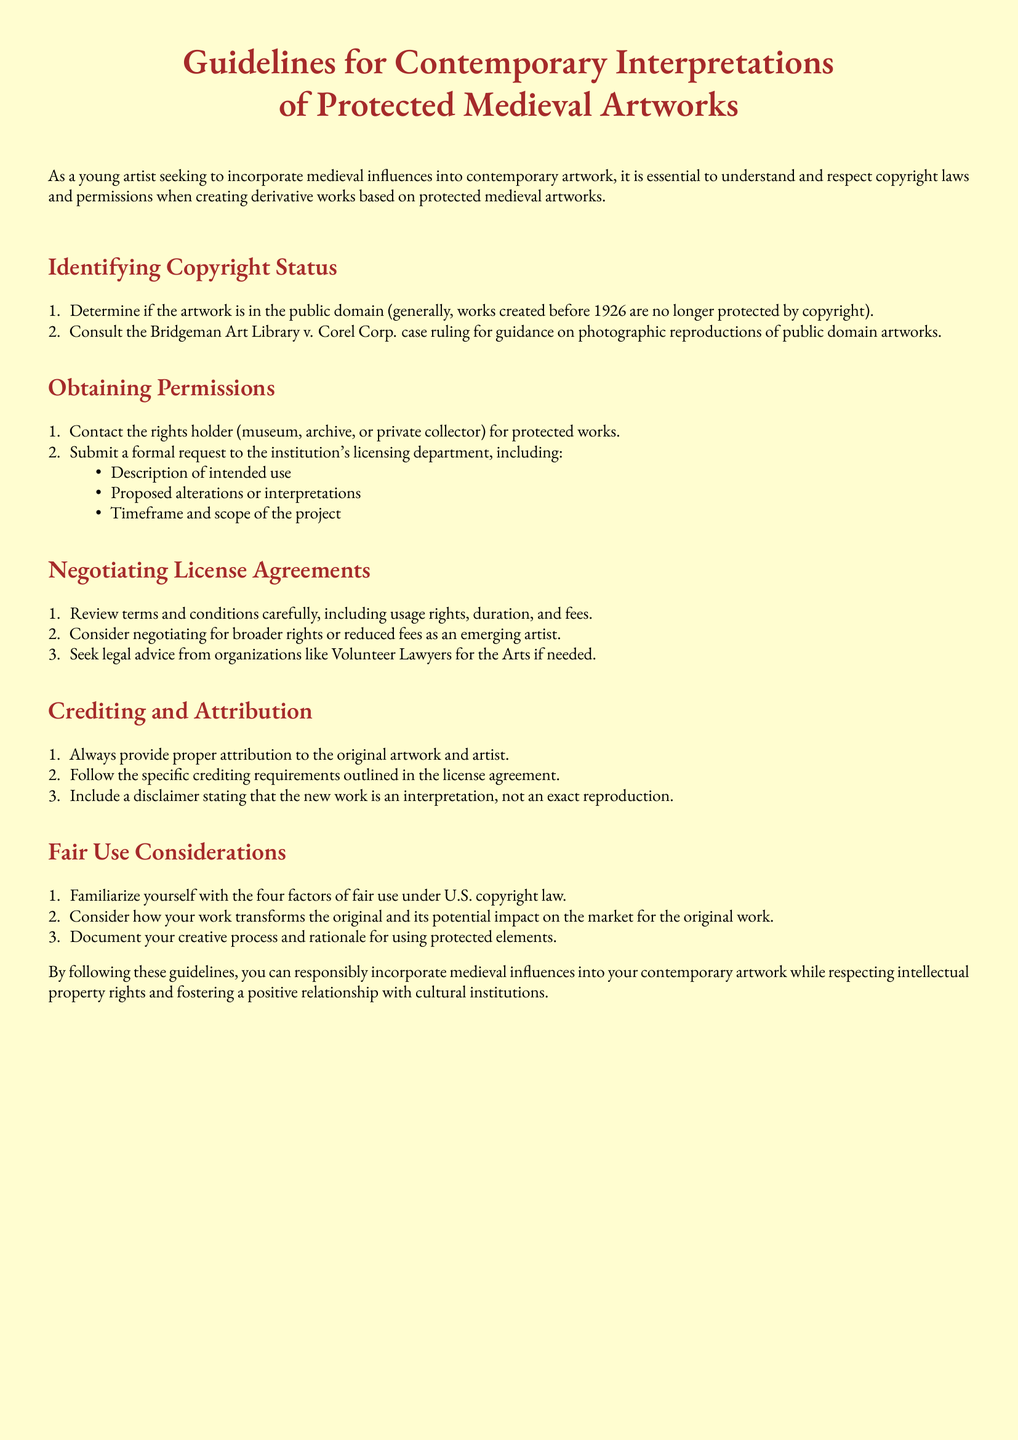What is the title of the document? The title is presented at the beginning of the document, which includes "Guidelines for Contemporary Interpretations of Protected Medieval Artworks."
Answer: Guidelines for Contemporary Interpretations of Protected Medieval Artworks What year do works typically enter public domain? The document states that works created before 1926 are no longer protected by copyright, indicating a general rule.
Answer: 1926 Who should be contacted for protected works? The document mentions contacting the rights holder, which could be a museum, archive, or private collector.
Answer: Rights holder What must be included in a formal request to the licensing department? The document specifies three elements that should be included in the request: a description of intended use, proposed alterations, and a timeframe.
Answer: Description of intended use, proposed alterations, timeframe What organization is suggested for legal advice? The document advises seeking legal aid from organizations that assist artists, specifically mentioning "Volunteer Lawyers for the Arts."
Answer: Volunteer Lawyers for the Arts What is the purpose of providing proper attribution? The document highlights the importance of attribution in giving credit to the original artwork and artist as part of responsible practice.
Answer: Credit to the original artwork and artist How many factors of fair use are outlined? The document states that there are four factors of fair use under U.S. copyright law.
Answer: Four What should be documented regarding the use of protected elements? The document advises documenting the creative process and rationale for using protected elements in your work.
Answer: Creative process and rationale 